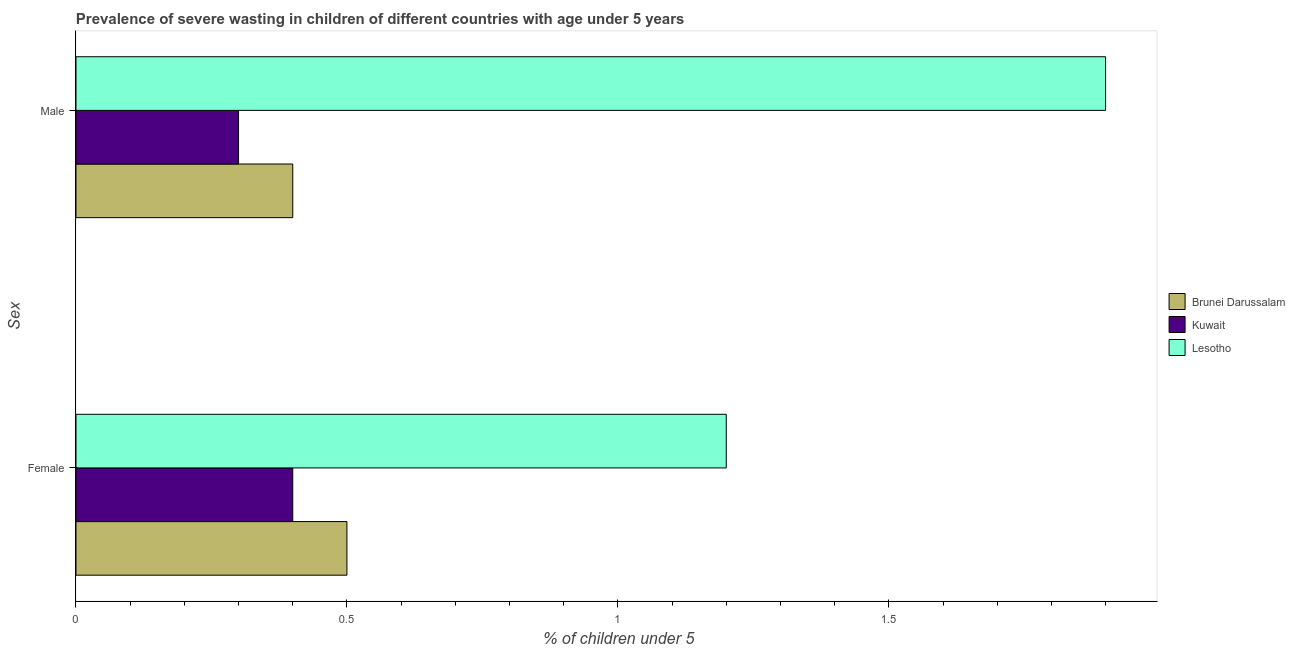How many different coloured bars are there?
Ensure brevity in your answer.  3. How many groups of bars are there?
Your answer should be compact. 2. How many bars are there on the 2nd tick from the top?
Offer a very short reply. 3. How many bars are there on the 1st tick from the bottom?
Provide a succinct answer. 3. What is the percentage of undernourished male children in Kuwait?
Keep it short and to the point. 0.3. Across all countries, what is the maximum percentage of undernourished female children?
Give a very brief answer. 1.2. Across all countries, what is the minimum percentage of undernourished female children?
Give a very brief answer. 0.4. In which country was the percentage of undernourished male children maximum?
Make the answer very short. Lesotho. In which country was the percentage of undernourished female children minimum?
Your answer should be compact. Kuwait. What is the total percentage of undernourished male children in the graph?
Keep it short and to the point. 2.6. What is the difference between the percentage of undernourished female children in Brunei Darussalam and that in Lesotho?
Offer a very short reply. -0.7. What is the difference between the percentage of undernourished male children in Kuwait and the percentage of undernourished female children in Brunei Darussalam?
Ensure brevity in your answer.  -0.2. What is the average percentage of undernourished female children per country?
Offer a terse response. 0.7. What is the difference between the percentage of undernourished female children and percentage of undernourished male children in Brunei Darussalam?
Make the answer very short. 0.1. In how many countries, is the percentage of undernourished male children greater than 1.3 %?
Offer a terse response. 1. What is the ratio of the percentage of undernourished male children in Brunei Darussalam to that in Lesotho?
Your answer should be very brief. 0.21. Is the percentage of undernourished male children in Kuwait less than that in Brunei Darussalam?
Your answer should be very brief. Yes. In how many countries, is the percentage of undernourished male children greater than the average percentage of undernourished male children taken over all countries?
Keep it short and to the point. 1. What does the 3rd bar from the top in Male represents?
Ensure brevity in your answer.  Brunei Darussalam. What does the 2nd bar from the bottom in Female represents?
Give a very brief answer. Kuwait. How many bars are there?
Provide a short and direct response. 6. How many countries are there in the graph?
Provide a succinct answer. 3. Are the values on the major ticks of X-axis written in scientific E-notation?
Your answer should be compact. No. Does the graph contain any zero values?
Give a very brief answer. No. Does the graph contain grids?
Keep it short and to the point. No. Where does the legend appear in the graph?
Ensure brevity in your answer.  Center right. How many legend labels are there?
Your response must be concise. 3. What is the title of the graph?
Your response must be concise. Prevalence of severe wasting in children of different countries with age under 5 years. Does "Other small states" appear as one of the legend labels in the graph?
Offer a very short reply. No. What is the label or title of the X-axis?
Ensure brevity in your answer.   % of children under 5. What is the label or title of the Y-axis?
Give a very brief answer. Sex. What is the  % of children under 5 in Brunei Darussalam in Female?
Your answer should be very brief. 0.5. What is the  % of children under 5 of Kuwait in Female?
Ensure brevity in your answer.  0.4. What is the  % of children under 5 in Lesotho in Female?
Your answer should be compact. 1.2. What is the  % of children under 5 in Brunei Darussalam in Male?
Give a very brief answer. 0.4. What is the  % of children under 5 of Kuwait in Male?
Offer a very short reply. 0.3. What is the  % of children under 5 in Lesotho in Male?
Your answer should be compact. 1.9. Across all Sex, what is the maximum  % of children under 5 in Brunei Darussalam?
Ensure brevity in your answer.  0.5. Across all Sex, what is the maximum  % of children under 5 of Kuwait?
Offer a terse response. 0.4. Across all Sex, what is the maximum  % of children under 5 in Lesotho?
Offer a terse response. 1.9. Across all Sex, what is the minimum  % of children under 5 of Brunei Darussalam?
Provide a short and direct response. 0.4. Across all Sex, what is the minimum  % of children under 5 in Kuwait?
Your response must be concise. 0.3. Across all Sex, what is the minimum  % of children under 5 in Lesotho?
Keep it short and to the point. 1.2. What is the total  % of children under 5 in Brunei Darussalam in the graph?
Make the answer very short. 0.9. What is the total  % of children under 5 in Kuwait in the graph?
Your response must be concise. 0.7. What is the difference between the  % of children under 5 in Brunei Darussalam in Female and that in Male?
Make the answer very short. 0.1. What is the difference between the  % of children under 5 of Lesotho in Female and that in Male?
Ensure brevity in your answer.  -0.7. What is the difference between the  % of children under 5 in Brunei Darussalam in Female and the  % of children under 5 in Kuwait in Male?
Provide a succinct answer. 0.2. What is the difference between the  % of children under 5 of Brunei Darussalam in Female and the  % of children under 5 of Lesotho in Male?
Your response must be concise. -1.4. What is the average  % of children under 5 in Brunei Darussalam per Sex?
Your answer should be very brief. 0.45. What is the average  % of children under 5 in Kuwait per Sex?
Your answer should be compact. 0.35. What is the average  % of children under 5 of Lesotho per Sex?
Your answer should be very brief. 1.55. What is the difference between the  % of children under 5 in Brunei Darussalam and  % of children under 5 in Lesotho in Female?
Provide a short and direct response. -0.7. What is the difference between the  % of children under 5 in Brunei Darussalam and  % of children under 5 in Lesotho in Male?
Offer a very short reply. -1.5. What is the ratio of the  % of children under 5 of Brunei Darussalam in Female to that in Male?
Give a very brief answer. 1.25. What is the ratio of the  % of children under 5 of Kuwait in Female to that in Male?
Ensure brevity in your answer.  1.33. What is the ratio of the  % of children under 5 in Lesotho in Female to that in Male?
Offer a terse response. 0.63. What is the difference between the highest and the second highest  % of children under 5 in Brunei Darussalam?
Provide a short and direct response. 0.1. What is the difference between the highest and the second highest  % of children under 5 of Kuwait?
Provide a succinct answer. 0.1. What is the difference between the highest and the lowest  % of children under 5 in Lesotho?
Your response must be concise. 0.7. 